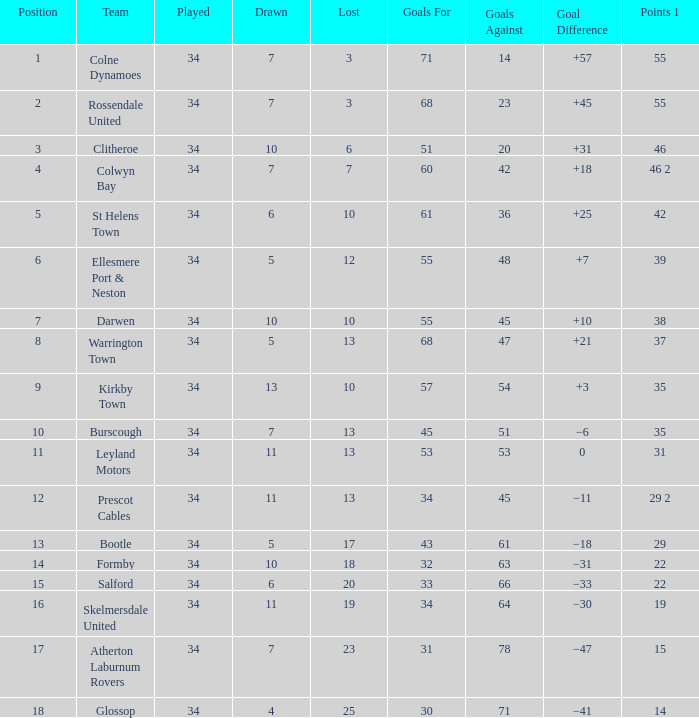Which Goals For has a Played larger than 34? None. 